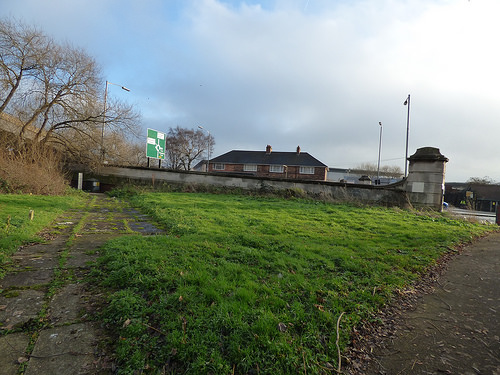<image>
Is there a lawn in front of the house? Yes. The lawn is positioned in front of the house, appearing closer to the camera viewpoint. 